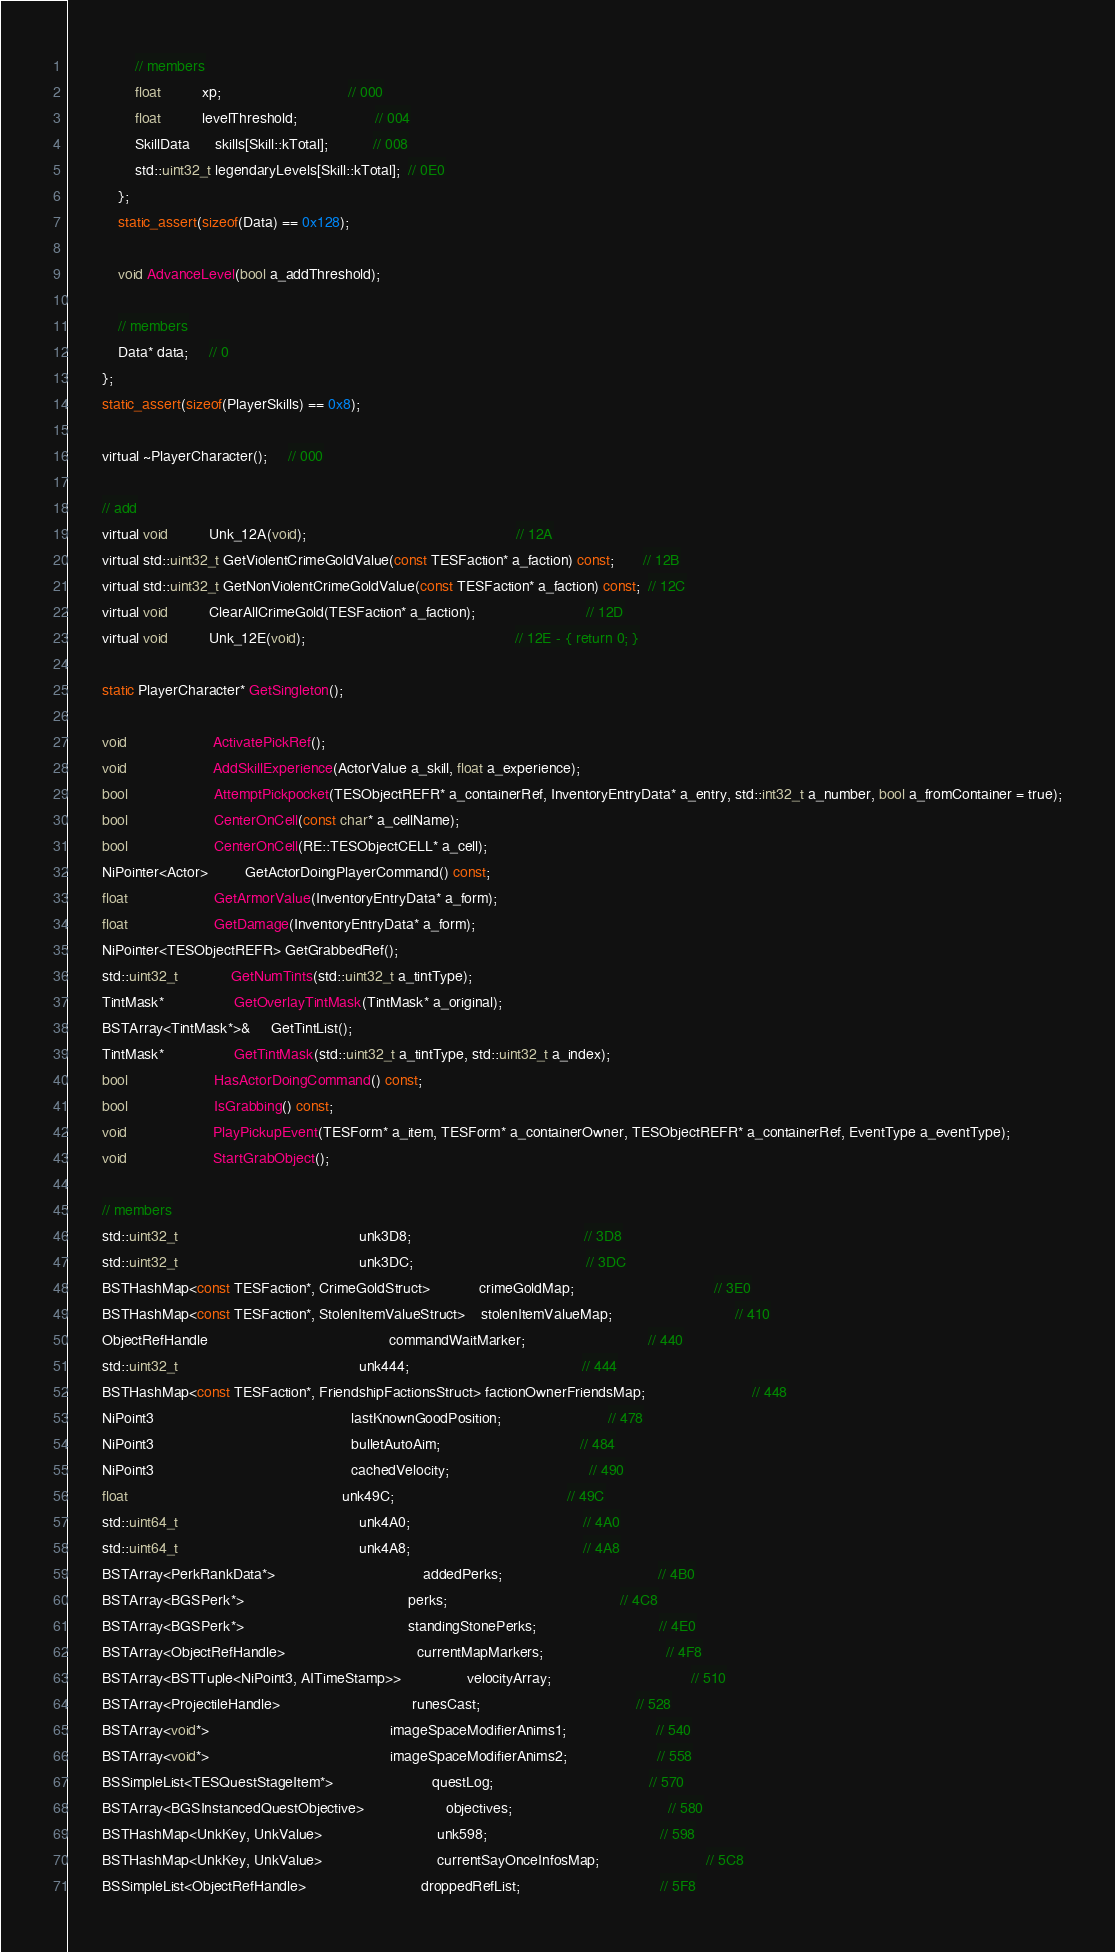Convert code to text. <code><loc_0><loc_0><loc_500><loc_500><_C_>				// members
				float		  xp;							   // 000
				float		  levelThreshold;				   // 004
				SkillData	  skills[Skill::kTotal];		   // 008
				std::uint32_t legendaryLevels[Skill::kTotal];  // 0E0
			};
			static_assert(sizeof(Data) == 0x128);

			void AdvanceLevel(bool a_addThreshold);

			// members
			Data* data;	 // 0
		};
		static_assert(sizeof(PlayerSkills) == 0x8);

		virtual ~PlayerCharacter();	 // 000

		// add
		virtual void		  Unk_12A(void);												   // 12A
		virtual std::uint32_t GetViolentCrimeGoldValue(const TESFaction* a_faction) const;	   // 12B
		virtual std::uint32_t GetNonViolentCrimeGoldValue(const TESFaction* a_faction) const;  // 12C
		virtual void		  ClearAllCrimeGold(TESFaction* a_faction);						   // 12D
		virtual void		  Unk_12E(void);												   // 12E - { return 0; }

		static PlayerCharacter* GetSingleton();

		void					 ActivatePickRef();
		void					 AddSkillExperience(ActorValue a_skill, float a_experience);
		bool					 AttemptPickpocket(TESObjectREFR* a_containerRef, InventoryEntryData* a_entry, std::int32_t a_number, bool a_fromContainer = true);
		bool					 CenterOnCell(const char* a_cellName);
		bool					 CenterOnCell(RE::TESObjectCELL* a_cell);
		NiPointer<Actor>		 GetActorDoingPlayerCommand() const;
		float					 GetArmorValue(InventoryEntryData* a_form);
		float					 GetDamage(InventoryEntryData* a_form);
		NiPointer<TESObjectREFR> GetGrabbedRef();
		std::uint32_t			 GetNumTints(std::uint32_t a_tintType);
		TintMask*				 GetOverlayTintMask(TintMask* a_original);
		BSTArray<TintMask*>&	 GetTintList();
		TintMask*				 GetTintMask(std::uint32_t a_tintType, std::uint32_t a_index);
		bool					 HasActorDoingCommand() const;
		bool					 IsGrabbing() const;
		void					 PlayPickupEvent(TESForm* a_item, TESForm* a_containerOwner, TESObjectREFR* a_containerRef, EventType a_eventType);
		void					 StartGrabObject();

		// members
		std::uint32_t											unk3D8;										  // 3D8
		std::uint32_t											unk3DC;										  // 3DC
		BSTHashMap<const TESFaction*, CrimeGoldStruct>			crimeGoldMap;								  // 3E0
		BSTHashMap<const TESFaction*, StolenItemValueStruct>	stolenItemValueMap;							  // 410
		ObjectRefHandle											commandWaitMarker;							  // 440
		std::uint32_t											unk444;										  // 444
		BSTHashMap<const TESFaction*, FriendshipFactionsStruct> factionOwnerFriendsMap;						  // 448
		NiPoint3												lastKnownGoodPosition;						  // 478
		NiPoint3												bulletAutoAim;								  // 484
		NiPoint3												cachedVelocity;								  // 490
		float													unk49C;										  // 49C
		std::uint64_t											unk4A0;										  // 4A0
		std::uint64_t											unk4A8;										  // 4A8
		BSTArray<PerkRankData*>									addedPerks;									  // 4B0
		BSTArray<BGSPerk*>										perks;										  // 4C8
		BSTArray<BGSPerk*>										standingStonePerks;							  // 4E0
		BSTArray<ObjectRefHandle>								currentMapMarkers;							  // 4F8
		BSTArray<BSTTuple<NiPoint3, AITimeStamp>>				velocityArray;								  // 510
		BSTArray<ProjectileHandle>								runesCast;									  // 528
		BSTArray<void*>											imageSpaceModifierAnims1;					  // 540
		BSTArray<void*>											imageSpaceModifierAnims2;					  // 558
		BSSimpleList<TESQuestStageItem*>						questLog;									  // 570
		BSTArray<BGSInstancedQuestObjective>					objectives;									  // 580
		BSTHashMap<UnkKey, UnkValue>							unk598;										  // 598
		BSTHashMap<UnkKey, UnkValue>							currentSayOnceInfosMap;						  // 5C8
		BSSimpleList<ObjectRefHandle>							droppedRefList;								  // 5F8</code> 